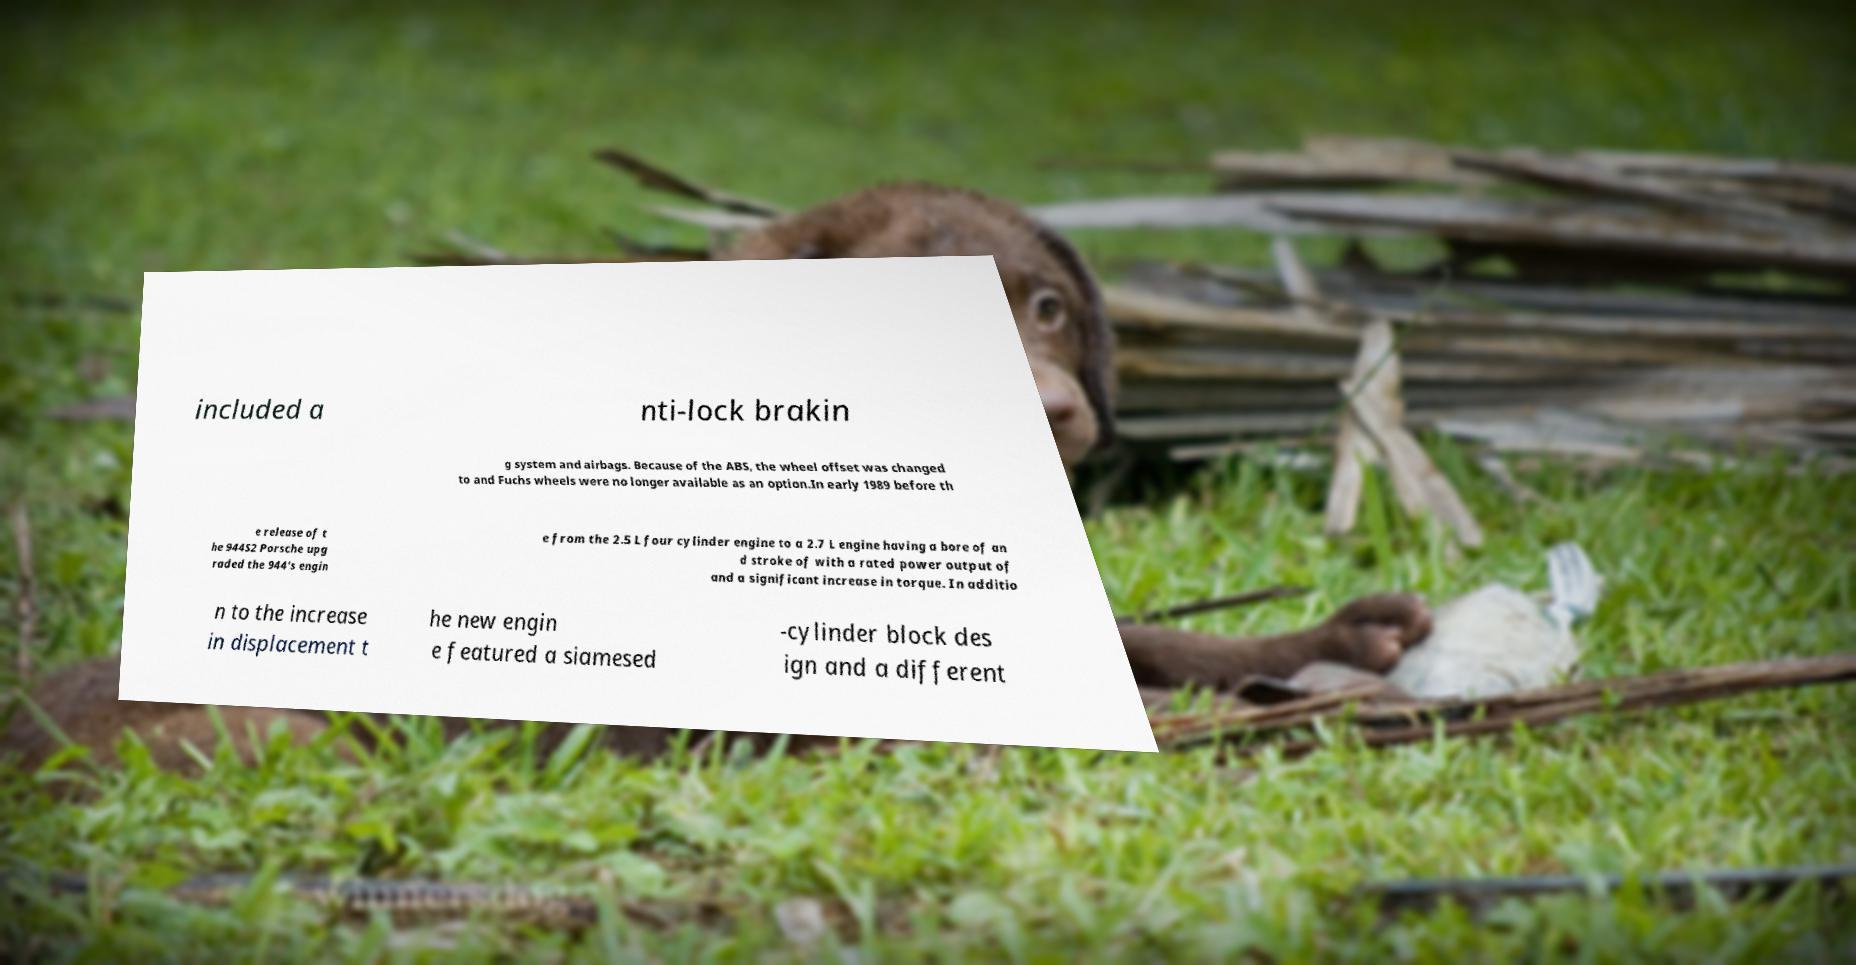Can you accurately transcribe the text from the provided image for me? included a nti-lock brakin g system and airbags. Because of the ABS, the wheel offset was changed to and Fuchs wheels were no longer available as an option.In early 1989 before th e release of t he 944S2 Porsche upg raded the 944's engin e from the 2.5 L four cylinder engine to a 2.7 L engine having a bore of an d stroke of with a rated power output of and a significant increase in torque. In additio n to the increase in displacement t he new engin e featured a siamesed -cylinder block des ign and a different 